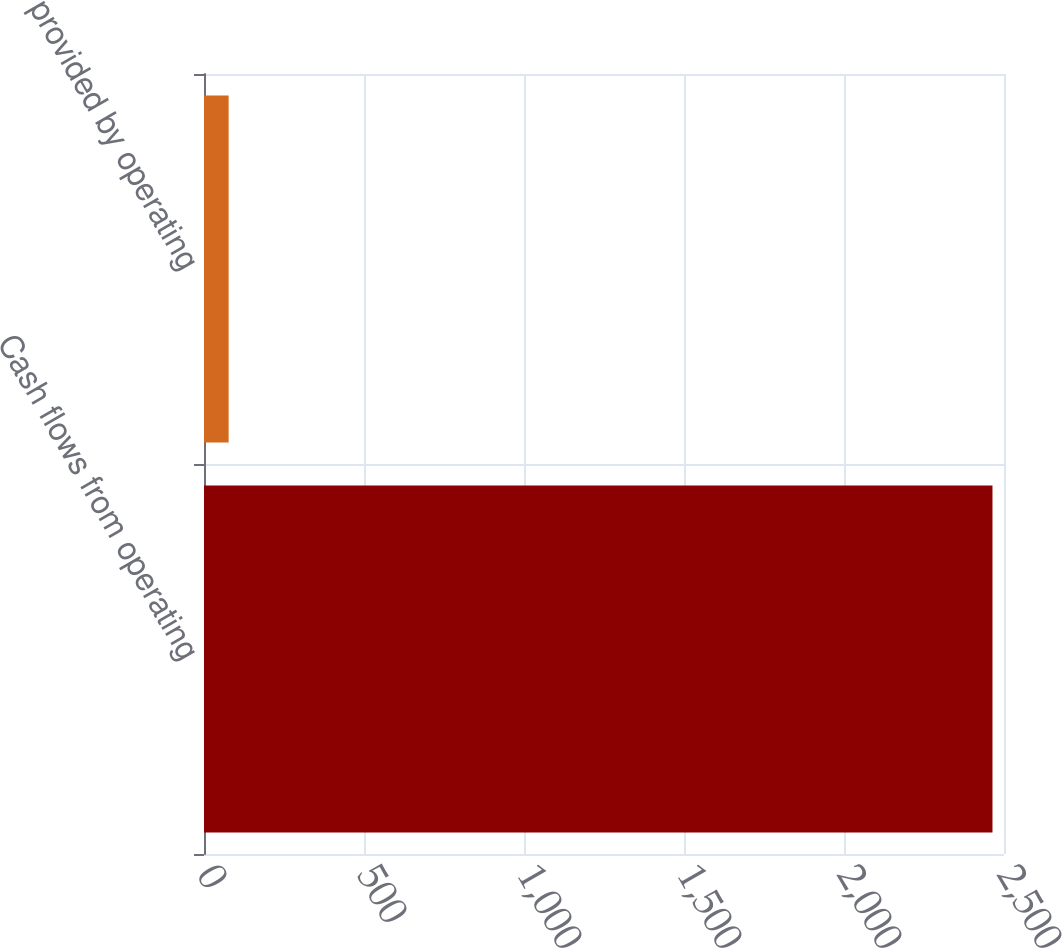Convert chart to OTSL. <chart><loc_0><loc_0><loc_500><loc_500><bar_chart><fcel>Cash flows from operating<fcel>provided by operating<nl><fcel>2464<fcel>77<nl></chart> 